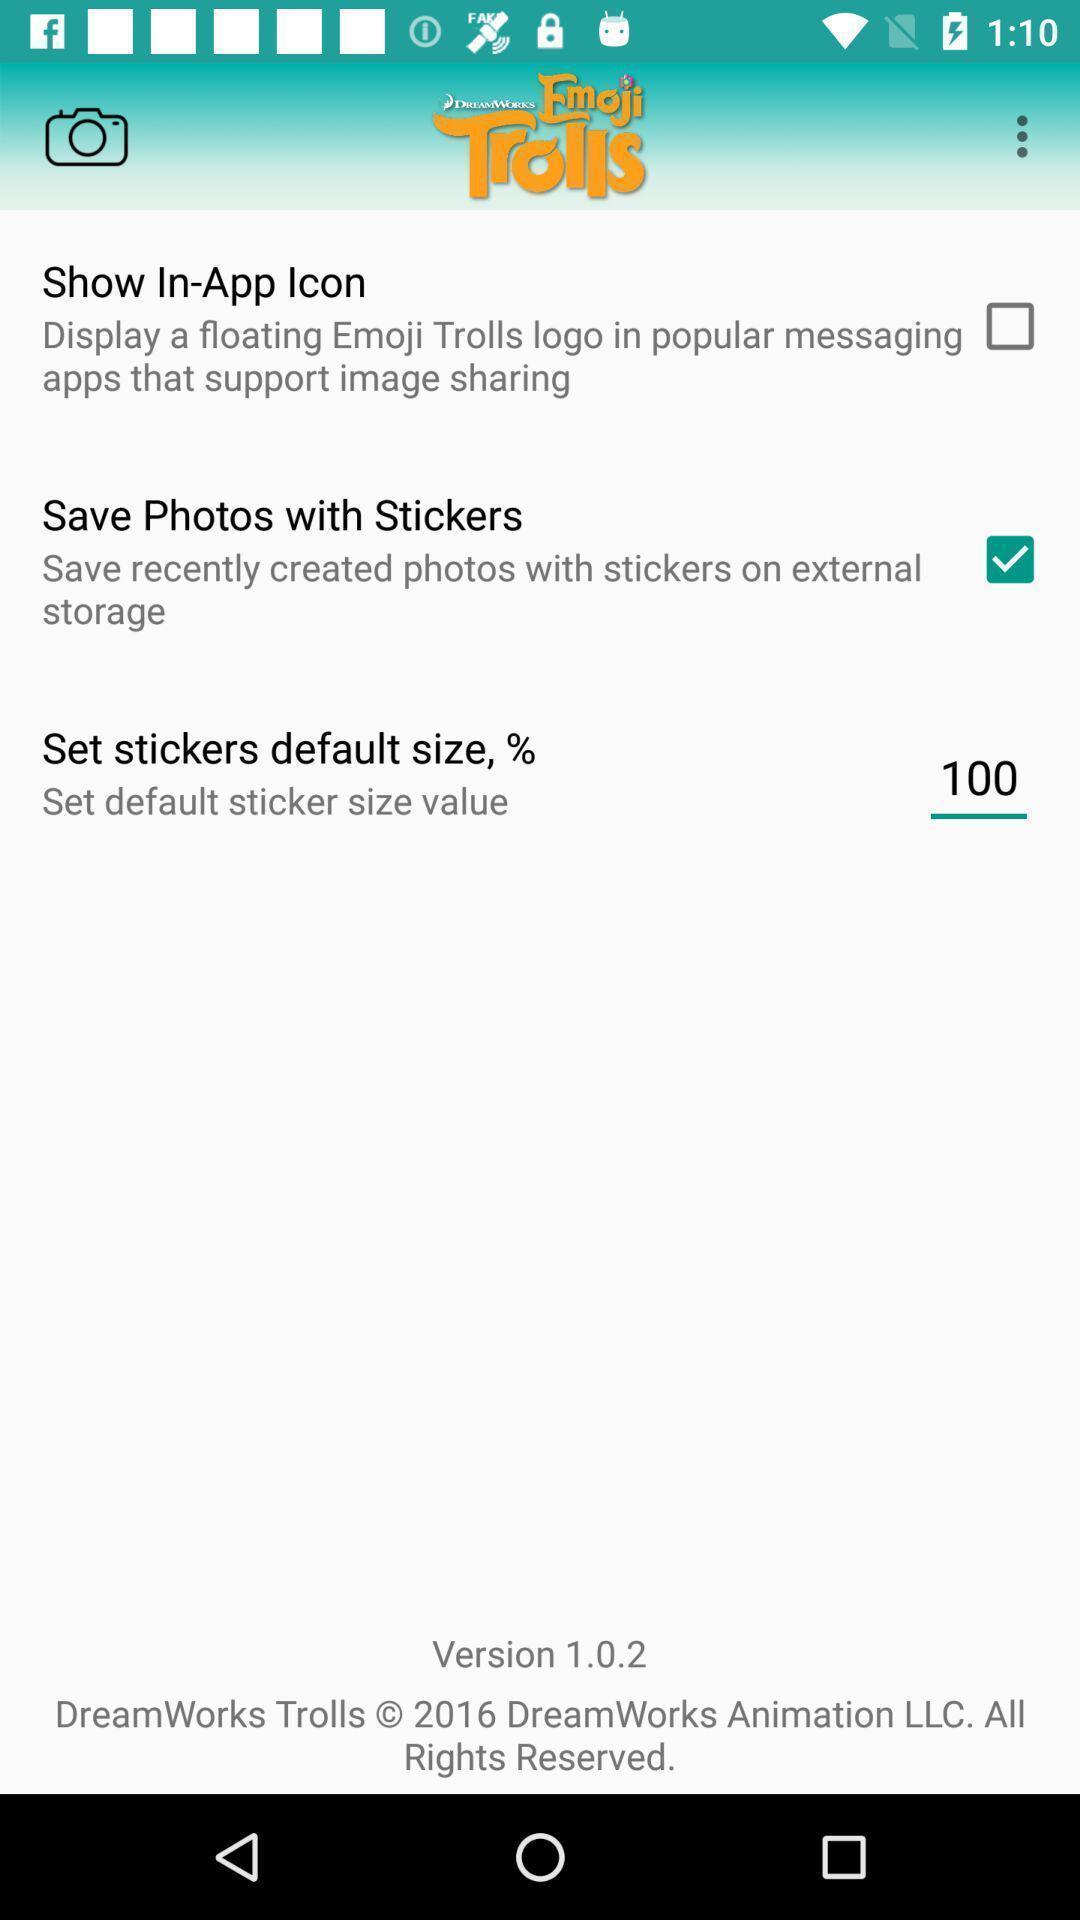What details can you identify in this image? Settings page. 